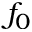Convert formula to latex. <formula><loc_0><loc_0><loc_500><loc_500>f _ { 0 }</formula> 